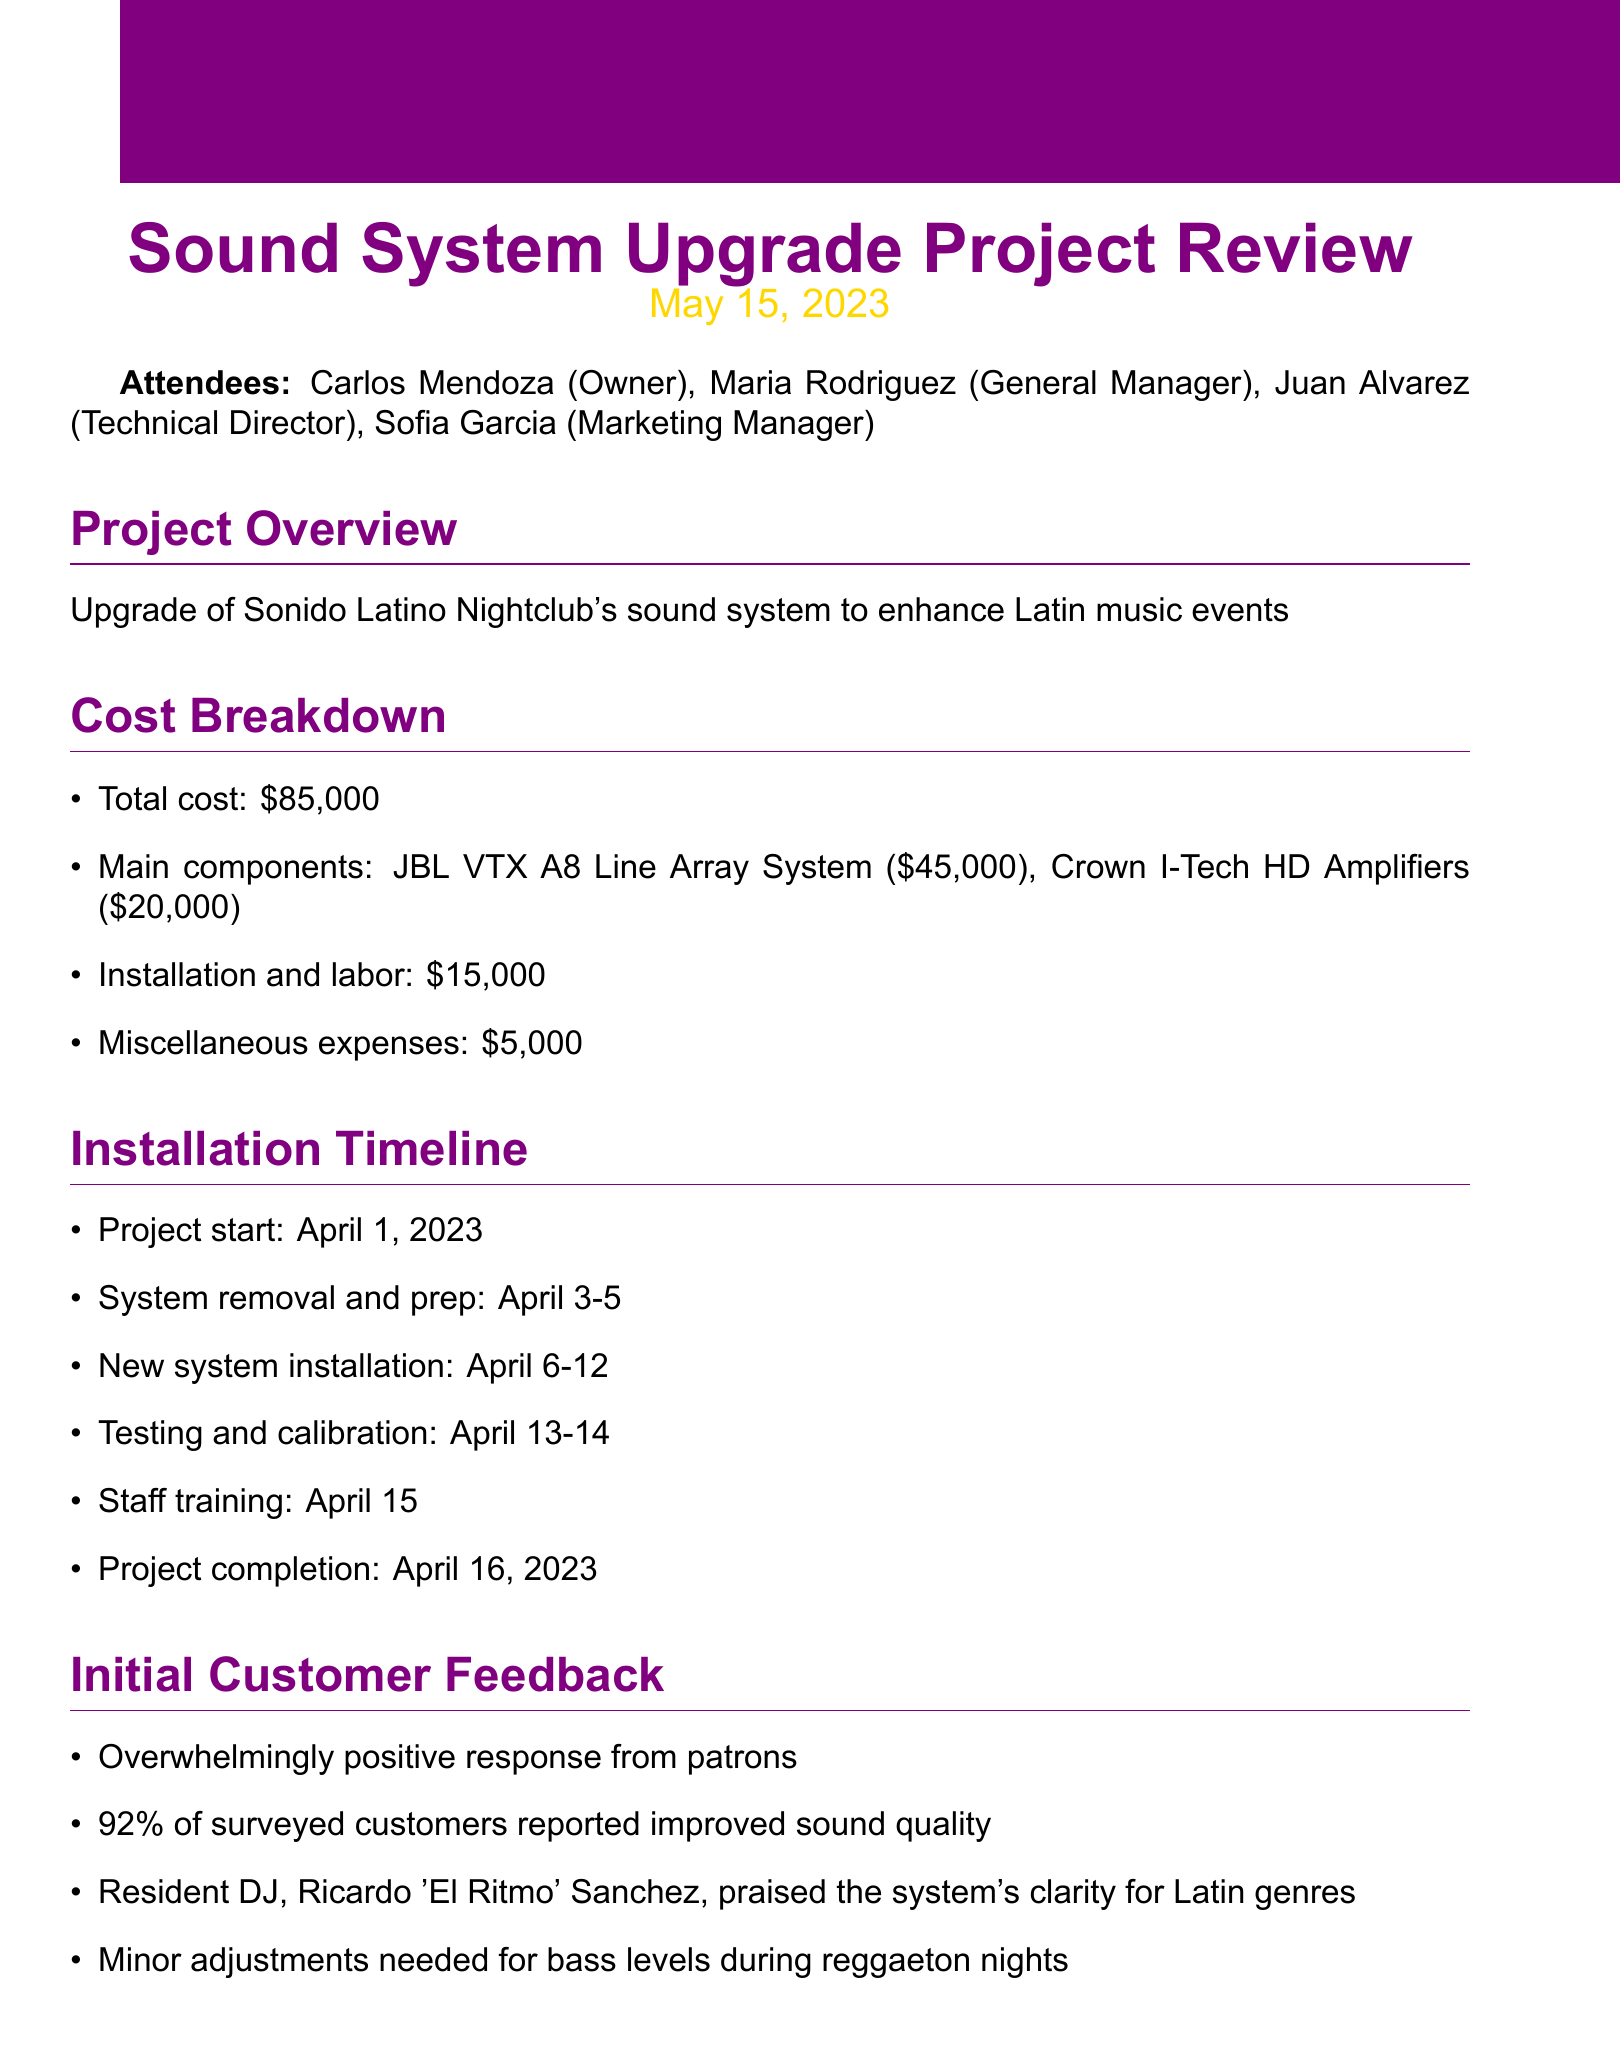What is the total cost of the sound system upgrade? The total cost is specified in the cost breakdown section of the document.
Answer: $85,000 When did the project start? The project start date is mentioned in the installation timeline of the document.
Answer: April 1, 2023 Who is the resident DJ mentioned in the feedback? The resident DJ's name is included in the initial customer feedback section.
Answer: Ricardo 'El Ritmo' Sanchez What percentage of customers reported improved sound quality? The percentage is stated in the initial customer feedback section.
Answer: 92% What was the installation and labor cost? The cost is detailed in the cost breakdown section.
Answer: $15,000 What specific adjustment is needed for bass levels? The required adjustment is found in the initial customer feedback section.
Answer: Minor adjustments needed for bass levels during reggaeton nights What is the completion date of the project? The project completion date is specified in the installation timeline section.
Answer: April 16, 2023 What is the first step in the next steps outlined? The first step is stated in the next steps section of the document.
Answer: Monitor ongoing feedback for the next month 